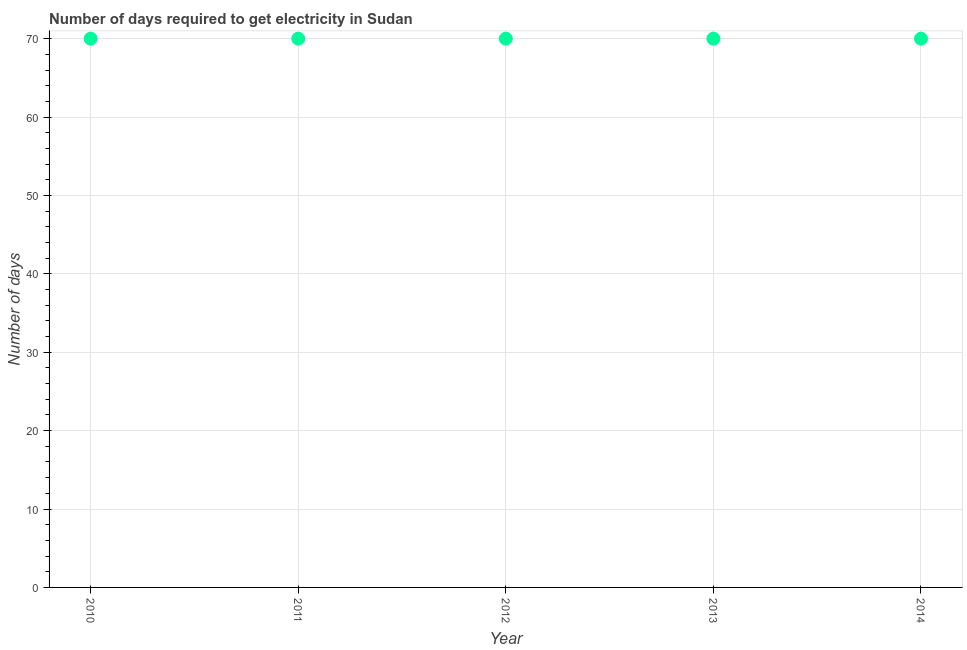What is the time to get electricity in 2013?
Your answer should be compact. 70. Across all years, what is the maximum time to get electricity?
Offer a very short reply. 70. Across all years, what is the minimum time to get electricity?
Your answer should be compact. 70. In which year was the time to get electricity maximum?
Your answer should be very brief. 2010. In which year was the time to get electricity minimum?
Your answer should be compact. 2010. What is the sum of the time to get electricity?
Ensure brevity in your answer.  350. What is the median time to get electricity?
Ensure brevity in your answer.  70. In how many years, is the time to get electricity greater than 4 ?
Make the answer very short. 5. What is the ratio of the time to get electricity in 2013 to that in 2014?
Offer a very short reply. 1. Is the time to get electricity in 2011 less than that in 2013?
Provide a succinct answer. No. Is the difference between the time to get electricity in 2010 and 2014 greater than the difference between any two years?
Make the answer very short. Yes. Is the sum of the time to get electricity in 2011 and 2012 greater than the maximum time to get electricity across all years?
Offer a terse response. Yes. How many dotlines are there?
Keep it short and to the point. 1. What is the difference between two consecutive major ticks on the Y-axis?
Provide a succinct answer. 10. Are the values on the major ticks of Y-axis written in scientific E-notation?
Make the answer very short. No. Does the graph contain any zero values?
Offer a terse response. No. What is the title of the graph?
Offer a very short reply. Number of days required to get electricity in Sudan. What is the label or title of the X-axis?
Give a very brief answer. Year. What is the label or title of the Y-axis?
Give a very brief answer. Number of days. What is the Number of days in 2010?
Offer a very short reply. 70. What is the Number of days in 2012?
Provide a short and direct response. 70. What is the Number of days in 2013?
Your answer should be very brief. 70. What is the Number of days in 2014?
Provide a succinct answer. 70. What is the difference between the Number of days in 2010 and 2011?
Provide a short and direct response. 0. What is the difference between the Number of days in 2010 and 2012?
Your response must be concise. 0. What is the difference between the Number of days in 2010 and 2013?
Offer a terse response. 0. What is the difference between the Number of days in 2011 and 2012?
Offer a terse response. 0. What is the difference between the Number of days in 2011 and 2014?
Your answer should be very brief. 0. What is the difference between the Number of days in 2012 and 2013?
Your response must be concise. 0. What is the difference between the Number of days in 2013 and 2014?
Make the answer very short. 0. What is the ratio of the Number of days in 2010 to that in 2012?
Your answer should be very brief. 1. What is the ratio of the Number of days in 2010 to that in 2014?
Offer a very short reply. 1. What is the ratio of the Number of days in 2011 to that in 2012?
Your answer should be very brief. 1. What is the ratio of the Number of days in 2011 to that in 2013?
Ensure brevity in your answer.  1. What is the ratio of the Number of days in 2012 to that in 2013?
Offer a terse response. 1. What is the ratio of the Number of days in 2012 to that in 2014?
Offer a very short reply. 1. 